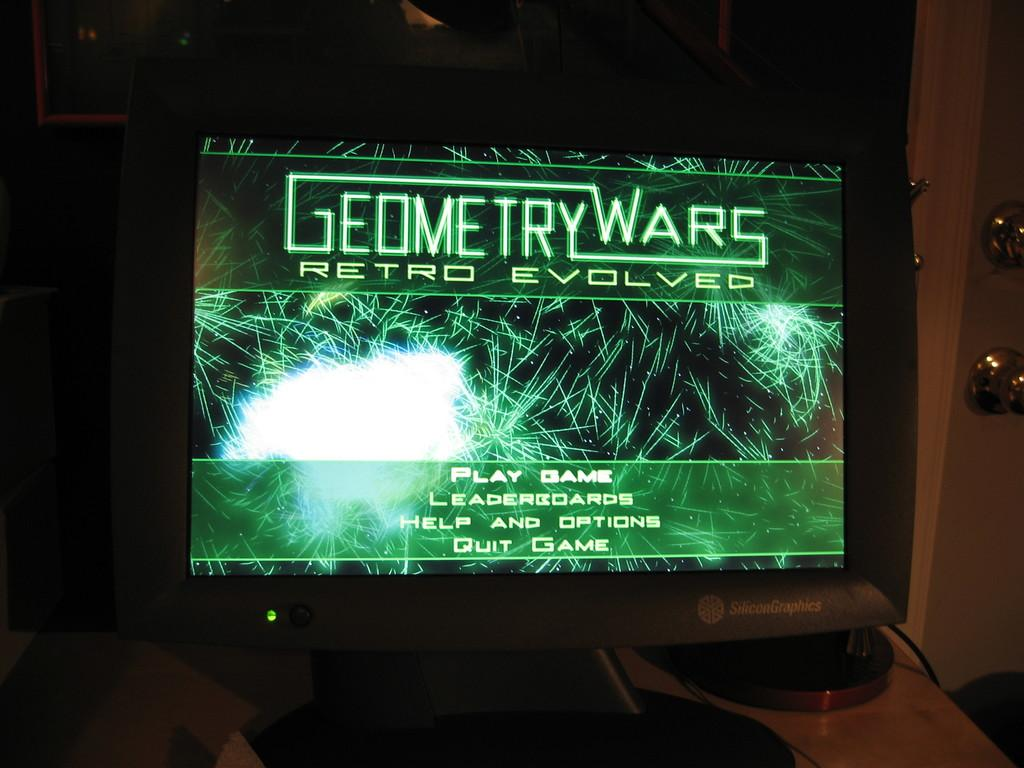<image>
Summarize the visual content of the image. A black computer monitor with a display screen that reads Geometry Wars Retro Evolved on a green background. 